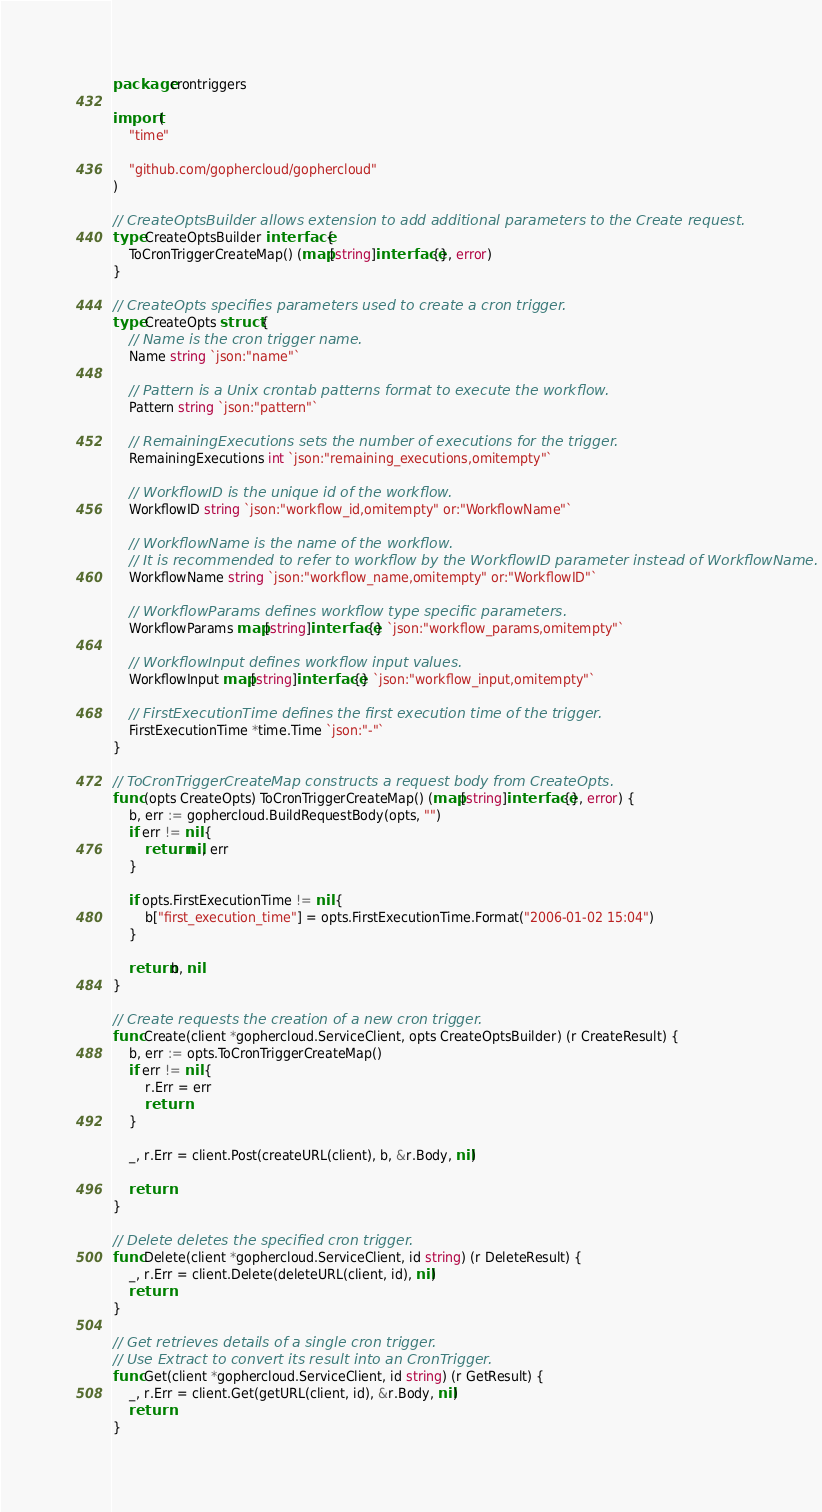<code> <loc_0><loc_0><loc_500><loc_500><_Go_>package crontriggers

import (
	"time"

	"github.com/gophercloud/gophercloud"
)

// CreateOptsBuilder allows extension to add additional parameters to the Create request.
type CreateOptsBuilder interface {
	ToCronTriggerCreateMap() (map[string]interface{}, error)
}

// CreateOpts specifies parameters used to create a cron trigger.
type CreateOpts struct {
	// Name is the cron trigger name.
	Name string `json:"name"`

	// Pattern is a Unix crontab patterns format to execute the workflow.
	Pattern string `json:"pattern"`

	// RemainingExecutions sets the number of executions for the trigger.
	RemainingExecutions int `json:"remaining_executions,omitempty"`

	// WorkflowID is the unique id of the workflow.
	WorkflowID string `json:"workflow_id,omitempty" or:"WorkflowName"`

	// WorkflowName is the name of the workflow.
	// It is recommended to refer to workflow by the WorkflowID parameter instead of WorkflowName.
	WorkflowName string `json:"workflow_name,omitempty" or:"WorkflowID"`

	// WorkflowParams defines workflow type specific parameters.
	WorkflowParams map[string]interface{} `json:"workflow_params,omitempty"`

	// WorkflowInput defines workflow input values.
	WorkflowInput map[string]interface{} `json:"workflow_input,omitempty"`

	// FirstExecutionTime defines the first execution time of the trigger.
	FirstExecutionTime *time.Time `json:"-"`
}

// ToCronTriggerCreateMap constructs a request body from CreateOpts.
func (opts CreateOpts) ToCronTriggerCreateMap() (map[string]interface{}, error) {
	b, err := gophercloud.BuildRequestBody(opts, "")
	if err != nil {
		return nil, err
	}

	if opts.FirstExecutionTime != nil {
		b["first_execution_time"] = opts.FirstExecutionTime.Format("2006-01-02 15:04")
	}

	return b, nil
}

// Create requests the creation of a new cron trigger.
func Create(client *gophercloud.ServiceClient, opts CreateOptsBuilder) (r CreateResult) {
	b, err := opts.ToCronTriggerCreateMap()
	if err != nil {
		r.Err = err
		return
	}

	_, r.Err = client.Post(createURL(client), b, &r.Body, nil)

	return
}

// Delete deletes the specified cron trigger.
func Delete(client *gophercloud.ServiceClient, id string) (r DeleteResult) {
	_, r.Err = client.Delete(deleteURL(client, id), nil)
	return
}

// Get retrieves details of a single cron trigger.
// Use Extract to convert its result into an CronTrigger.
func Get(client *gophercloud.ServiceClient, id string) (r GetResult) {
	_, r.Err = client.Get(getURL(client, id), &r.Body, nil)
	return
}
</code> 